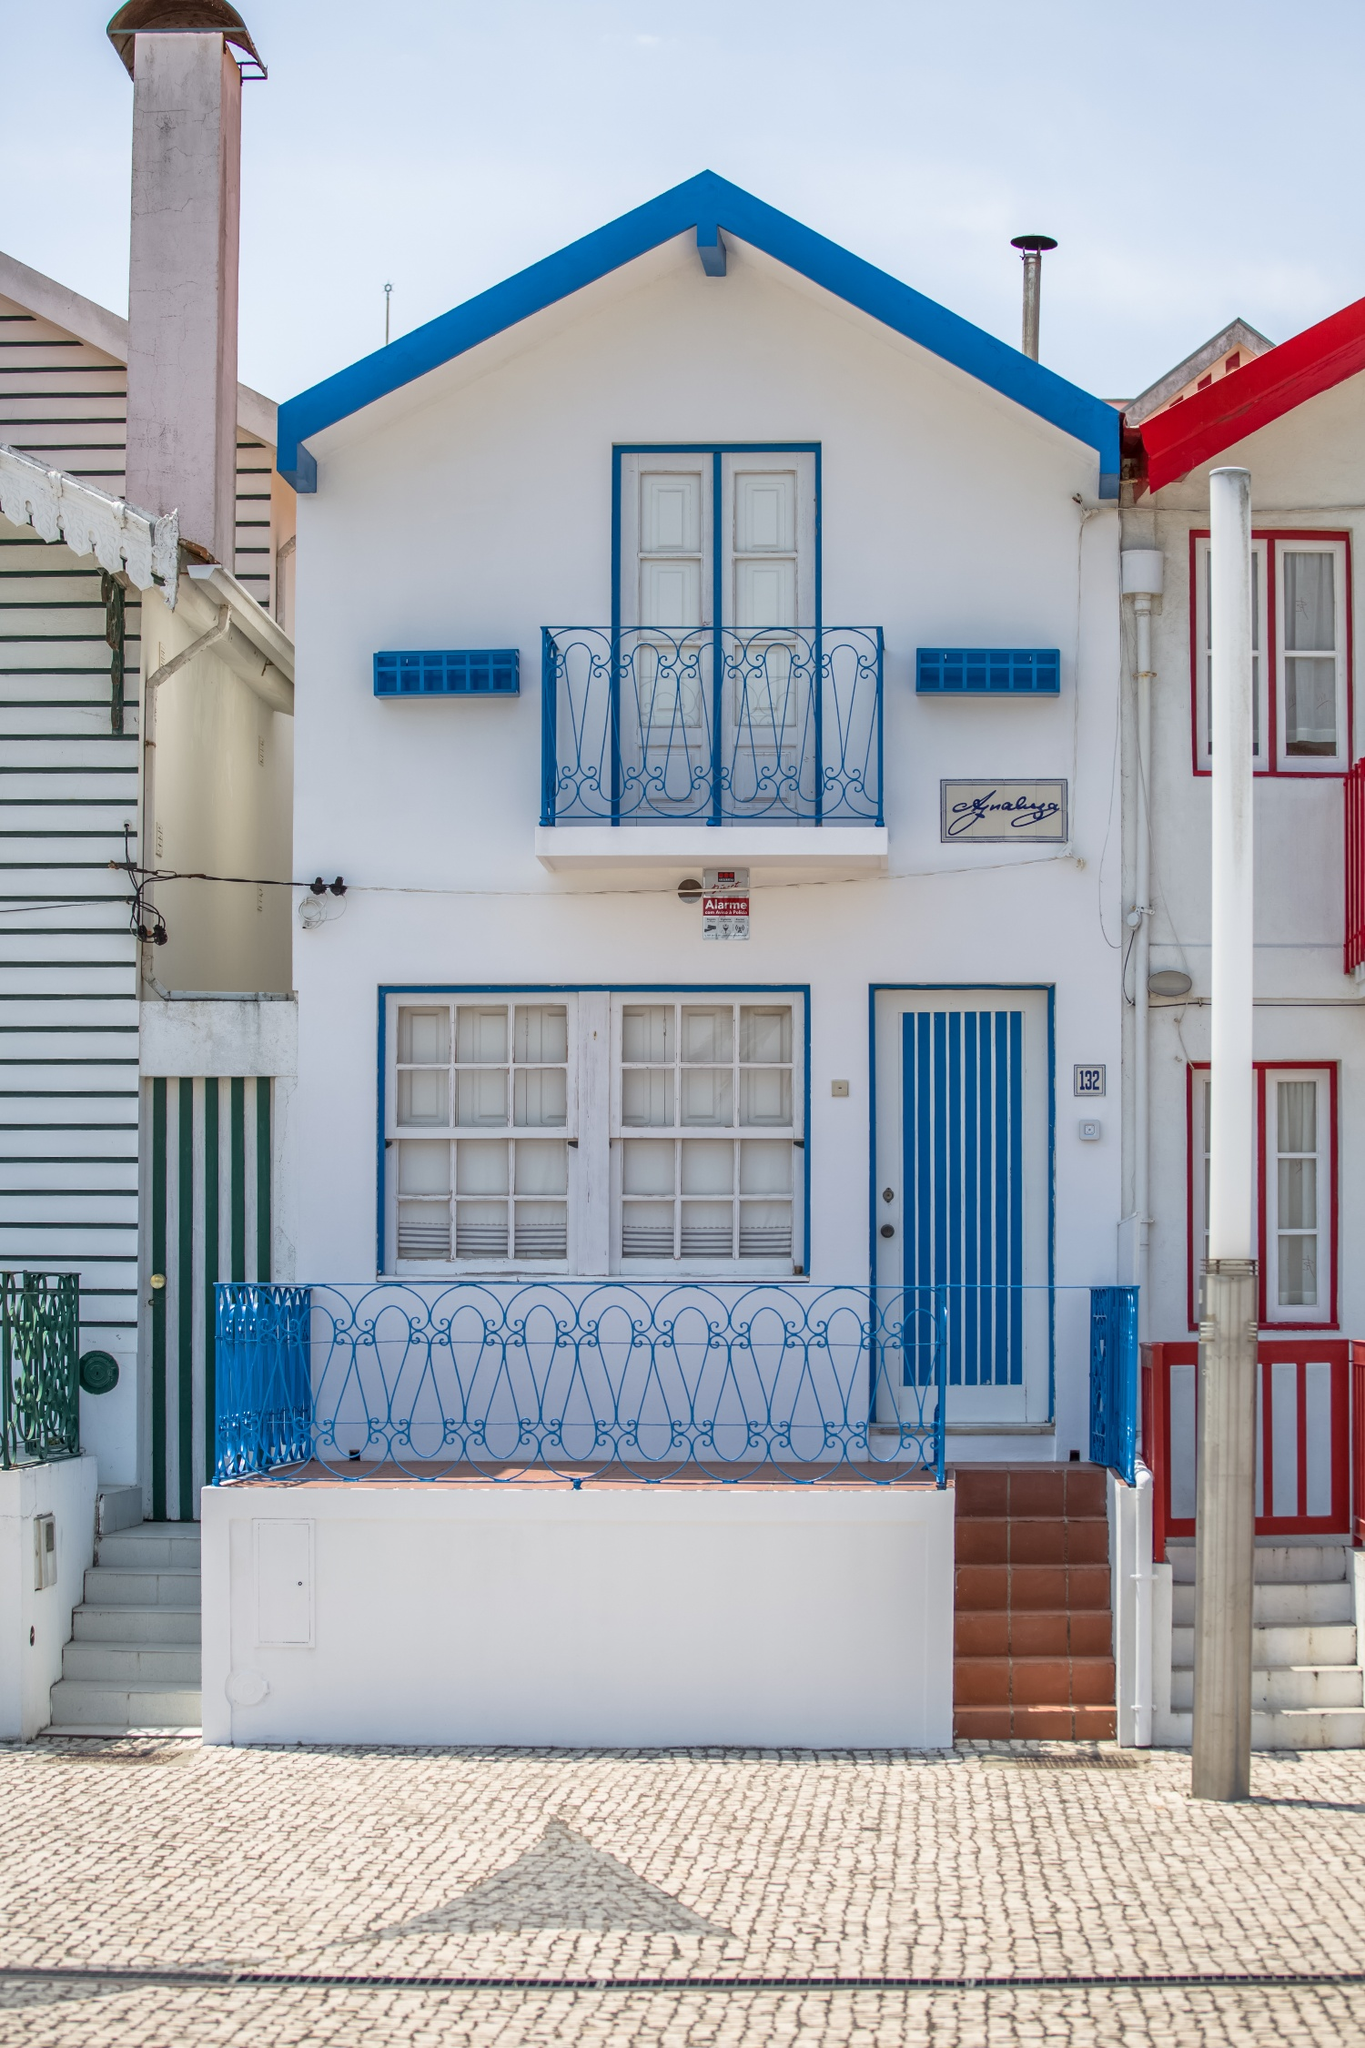What is this photo about? The image features a picturesque house notable for its striking color scheme and quaint architectural details, nestled in a tight row of similarly unique homes. Painted in a bright white with bold blue accents on the door and balcony railing, the house stands out vividly. The roof is tiled in a red tone, adding contrast and a touch of traditional charm. This particular house, likely situated in a coastal European town given the style and 'Casa da Praia' sign which translates to 'Beach House', encapsulates a warm, inviting atmosphere. Distinctive details like the cobblestone street and neighboring houses adorned in varying colors and designs suggest a vibrant community possibly set in a historically rich locale. 